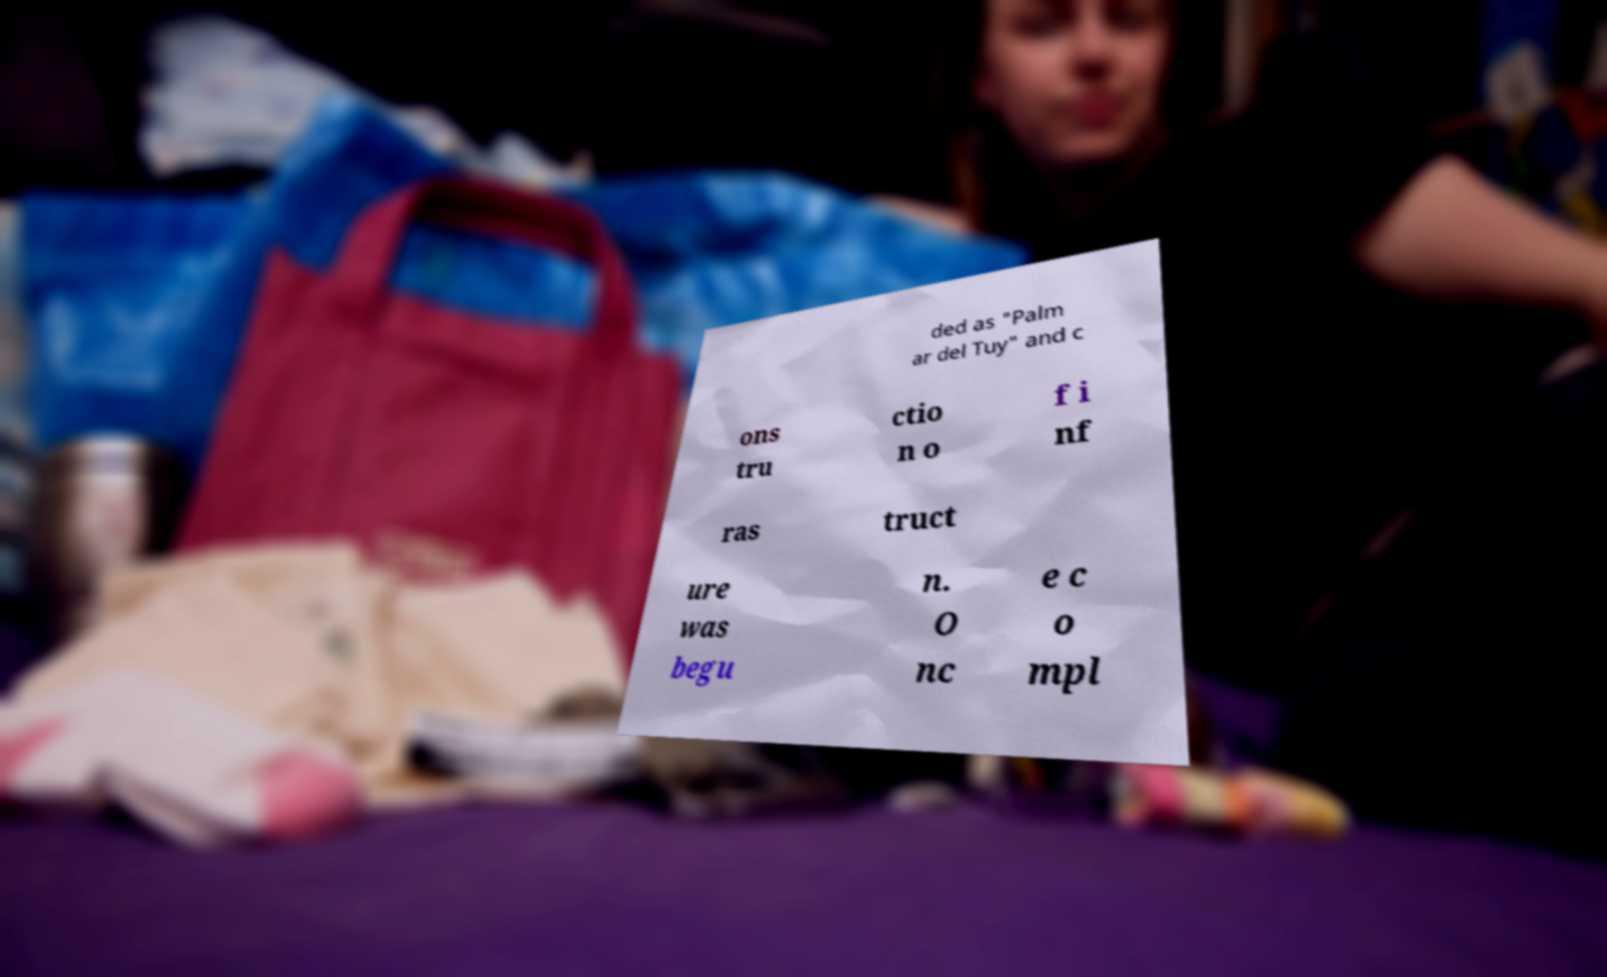Please identify and transcribe the text found in this image. ded as "Palm ar del Tuy" and c ons tru ctio n o f i nf ras truct ure was begu n. O nc e c o mpl 